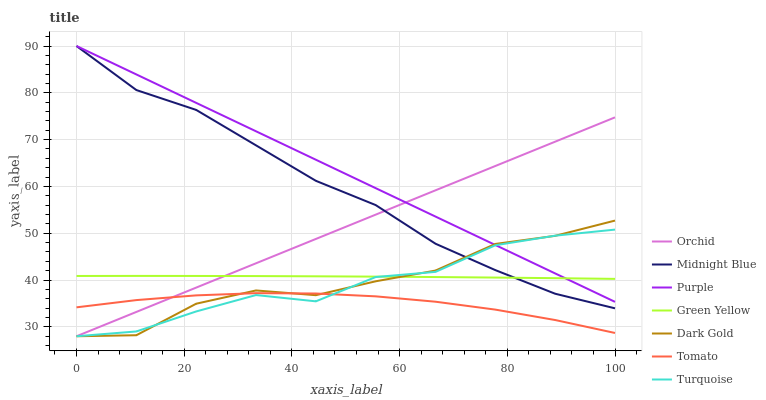Does Tomato have the minimum area under the curve?
Answer yes or no. Yes. Does Purple have the maximum area under the curve?
Answer yes or no. Yes. Does Turquoise have the minimum area under the curve?
Answer yes or no. No. Does Turquoise have the maximum area under the curve?
Answer yes or no. No. Is Orchid the smoothest?
Answer yes or no. Yes. Is Turquoise the roughest?
Answer yes or no. Yes. Is Midnight Blue the smoothest?
Answer yes or no. No. Is Midnight Blue the roughest?
Answer yes or no. No. Does Turquoise have the lowest value?
Answer yes or no. Yes. Does Midnight Blue have the lowest value?
Answer yes or no. No. Does Purple have the highest value?
Answer yes or no. Yes. Does Turquoise have the highest value?
Answer yes or no. No. Is Tomato less than Purple?
Answer yes or no. Yes. Is Green Yellow greater than Tomato?
Answer yes or no. Yes. Does Midnight Blue intersect Orchid?
Answer yes or no. Yes. Is Midnight Blue less than Orchid?
Answer yes or no. No. Is Midnight Blue greater than Orchid?
Answer yes or no. No. Does Tomato intersect Purple?
Answer yes or no. No. 